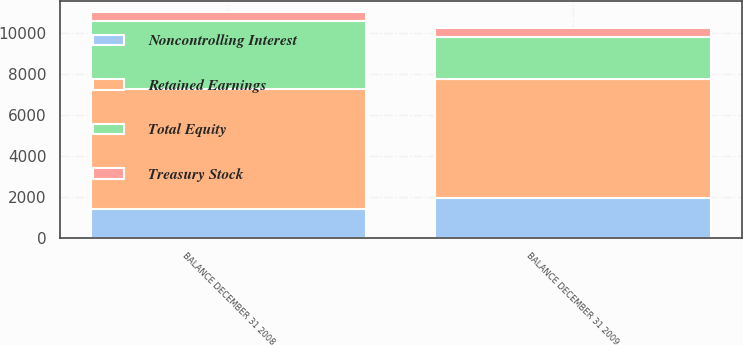Convert chart. <chart><loc_0><loc_0><loc_500><loc_500><stacked_bar_chart><ecel><fcel>BALANCE DECEMBER 31 2008<fcel>BALANCE DECEMBER 31 2009<nl><fcel>Treasury Stock<fcel>434<fcel>437<nl><fcel>Retained Earnings<fcel>5845<fcel>5803<nl><fcel>Noncontrolling Interest<fcel>1430<fcel>1949<nl><fcel>Total Equity<fcel>3322<fcel>2077<nl></chart> 